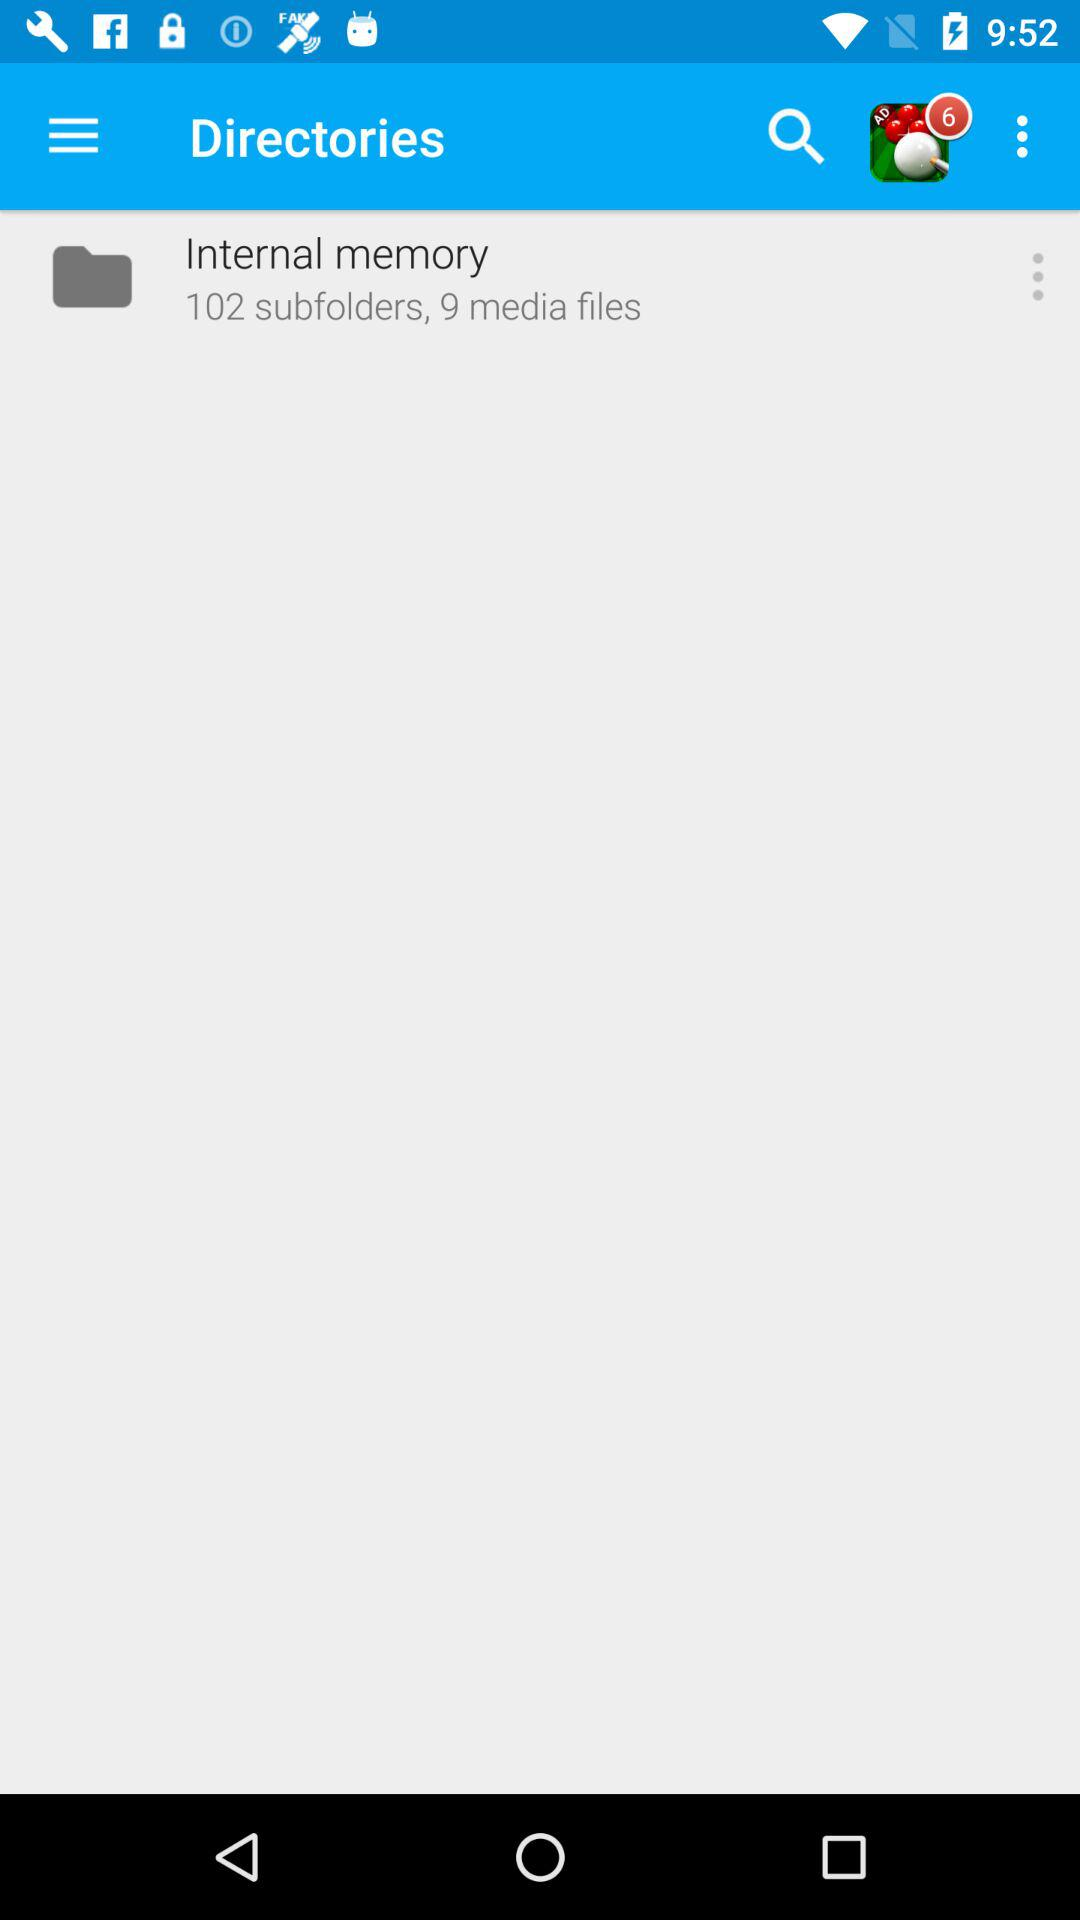How many subfolders are there in the internal memory? There are 102 subfolders. 